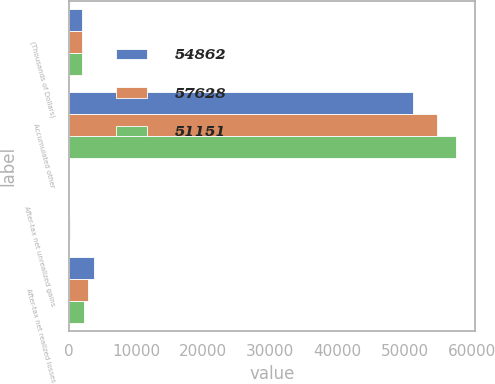<chart> <loc_0><loc_0><loc_500><loc_500><stacked_bar_chart><ecel><fcel>(Thousands of Dollars)<fcel>Accumulated other<fcel>After-tax net unrealized gains<fcel>After-tax net realized losses<nl><fcel>54862<fcel>2016<fcel>51151<fcel>3<fcel>3708<nl><fcel>57628<fcel>2015<fcel>54862<fcel>70<fcel>2836<nl><fcel>51151<fcel>2014<fcel>57628<fcel>163<fcel>2288<nl></chart> 